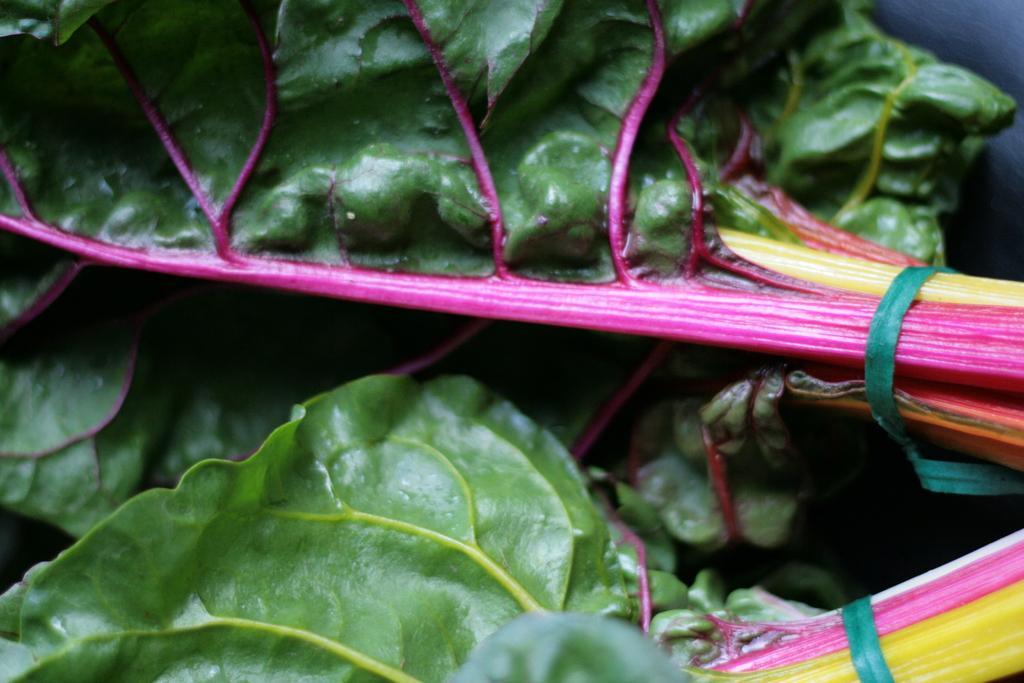What type of food is visible in the center of the image? There are green leafy vegetables in the center of the image. How does the yam contribute to the rainstorm in the image? There is no yam or rainstorm present in the image; it only features green leafy vegetables. 